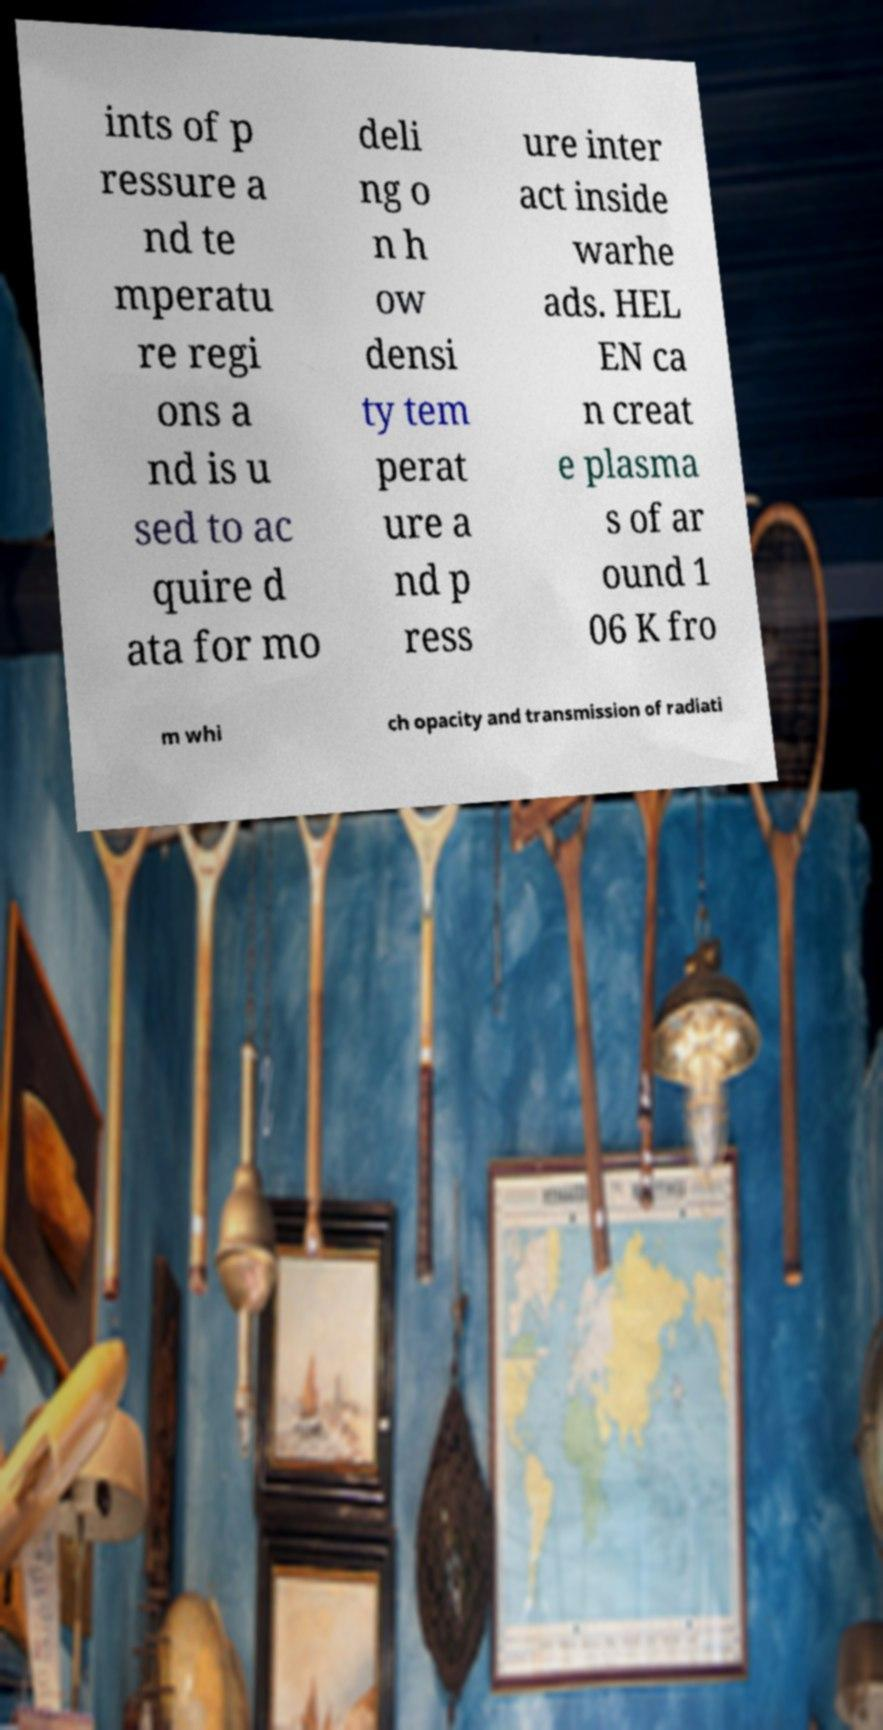For documentation purposes, I need the text within this image transcribed. Could you provide that? ints of p ressure a nd te mperatu re regi ons a nd is u sed to ac quire d ata for mo deli ng o n h ow densi ty tem perat ure a nd p ress ure inter act inside warhe ads. HEL EN ca n creat e plasma s of ar ound 1 06 K fro m whi ch opacity and transmission of radiati 